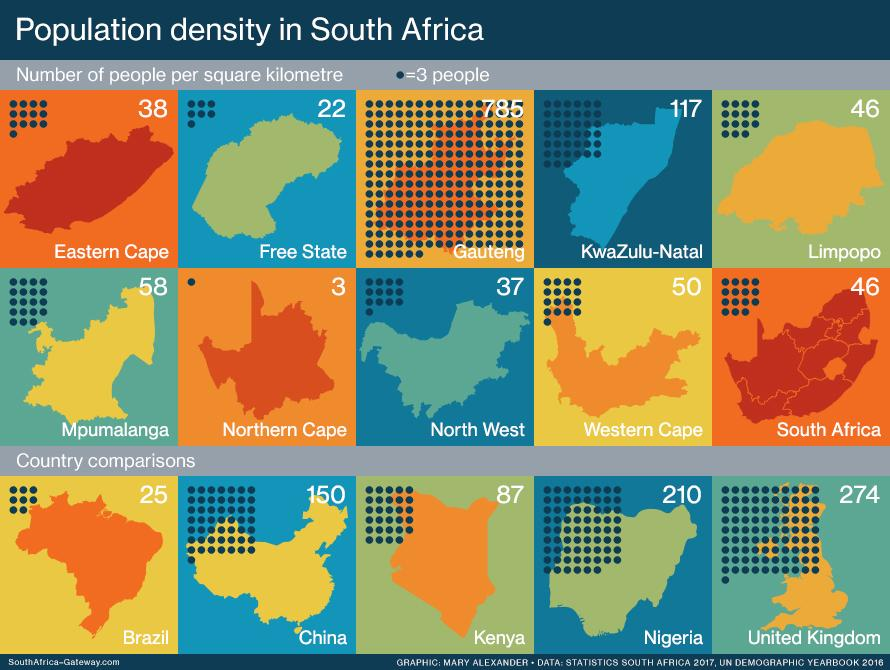Draw attention to some important aspects in this diagram. Brazil is the least densely populated country in the world. Gauteng is the province of South Africa that is most densely populated. The Northern Cape province of South Africa is the least densely populated province in the country. The country with the highest population density is the United Kingdom. 